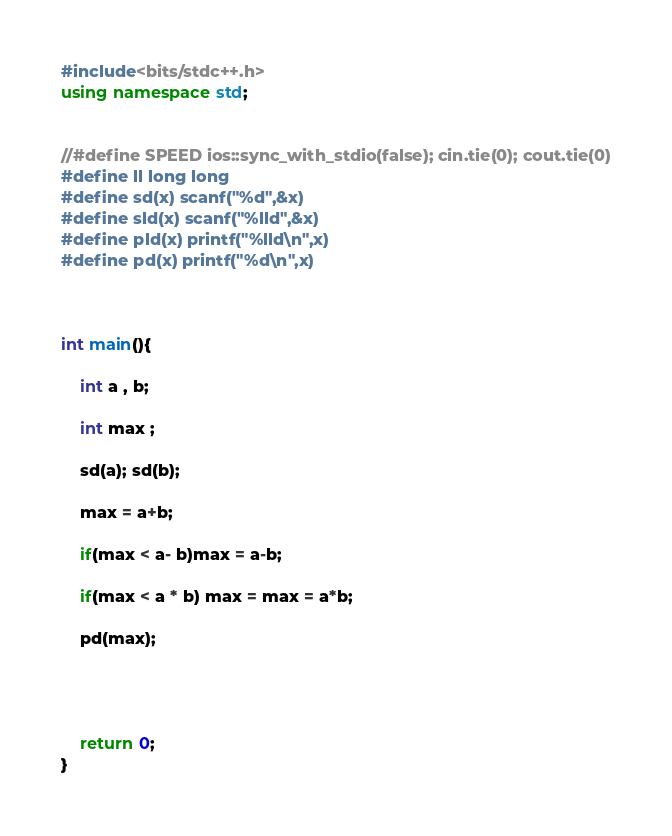<code> <loc_0><loc_0><loc_500><loc_500><_C++_>#include<bits/stdc++.h>
using namespace std;
     
     
//#define SPEED ios::sync_with_stdio(false); cin.tie(0); cout.tie(0)
#define ll long long
#define sd(x) scanf("%d",&x)
#define sld(x) scanf("%lld",&x)
#define pld(x) printf("%lld\n",x)
#define pd(x) printf("%d\n",x)

     
     
int main(){

	int a , b;

	int max ;

	sd(a); sd(b); 

	max = a+b;

	if(max < a- b)max = a-b;

	if(max < a * b) max = max = a*b;

	pd(max);
           
     
     
        
    return 0;
}
</code> 